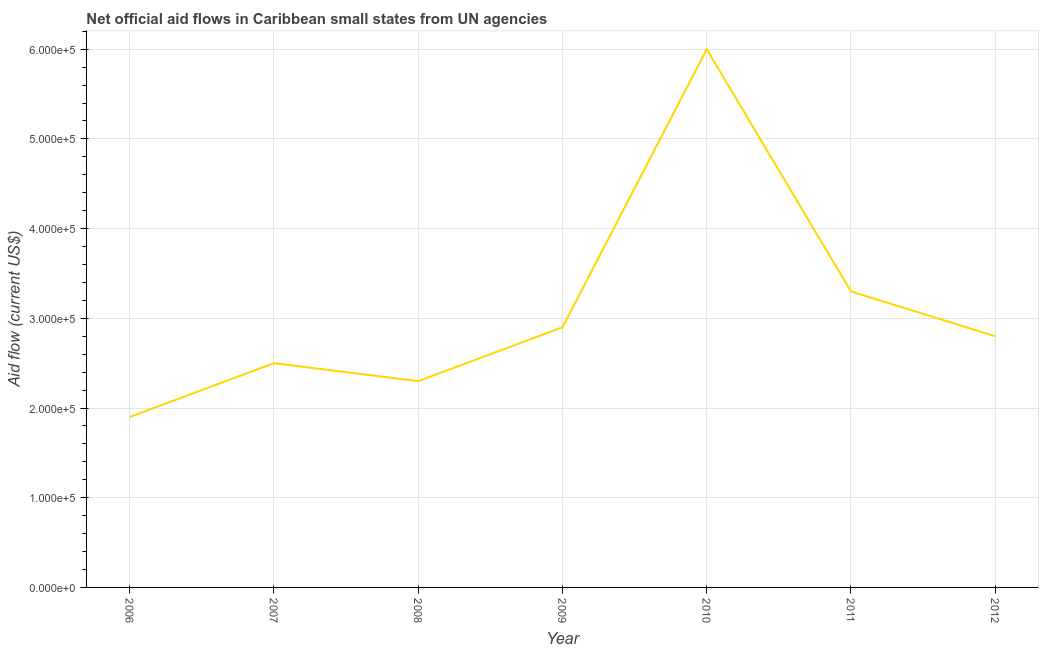What is the net official flows from un agencies in 2007?
Give a very brief answer. 2.50e+05. Across all years, what is the maximum net official flows from un agencies?
Make the answer very short. 6.00e+05. Across all years, what is the minimum net official flows from un agencies?
Offer a terse response. 1.90e+05. What is the sum of the net official flows from un agencies?
Provide a succinct answer. 2.17e+06. What is the difference between the net official flows from un agencies in 2009 and 2011?
Ensure brevity in your answer.  -4.00e+04. What is the average net official flows from un agencies per year?
Give a very brief answer. 3.10e+05. What is the median net official flows from un agencies?
Your response must be concise. 2.80e+05. In how many years, is the net official flows from un agencies greater than 300000 US$?
Your response must be concise. 2. Do a majority of the years between 2010 and 2009 (inclusive) have net official flows from un agencies greater than 380000 US$?
Keep it short and to the point. No. What is the ratio of the net official flows from un agencies in 2006 to that in 2009?
Give a very brief answer. 0.66. Is the net official flows from un agencies in 2010 less than that in 2011?
Offer a very short reply. No. What is the difference between the highest and the lowest net official flows from un agencies?
Your answer should be very brief. 4.10e+05. Does the net official flows from un agencies monotonically increase over the years?
Your answer should be very brief. No. How many years are there in the graph?
Provide a short and direct response. 7. Are the values on the major ticks of Y-axis written in scientific E-notation?
Keep it short and to the point. Yes. Does the graph contain grids?
Offer a terse response. Yes. What is the title of the graph?
Your response must be concise. Net official aid flows in Caribbean small states from UN agencies. What is the Aid flow (current US$) of 2006?
Your answer should be compact. 1.90e+05. What is the Aid flow (current US$) in 2007?
Ensure brevity in your answer.  2.50e+05. What is the Aid flow (current US$) in 2008?
Offer a terse response. 2.30e+05. What is the Aid flow (current US$) of 2010?
Provide a succinct answer. 6.00e+05. What is the Aid flow (current US$) of 2012?
Provide a succinct answer. 2.80e+05. What is the difference between the Aid flow (current US$) in 2006 and 2007?
Keep it short and to the point. -6.00e+04. What is the difference between the Aid flow (current US$) in 2006 and 2010?
Ensure brevity in your answer.  -4.10e+05. What is the difference between the Aid flow (current US$) in 2006 and 2011?
Offer a terse response. -1.40e+05. What is the difference between the Aid flow (current US$) in 2006 and 2012?
Make the answer very short. -9.00e+04. What is the difference between the Aid flow (current US$) in 2007 and 2008?
Your answer should be very brief. 2.00e+04. What is the difference between the Aid flow (current US$) in 2007 and 2009?
Make the answer very short. -4.00e+04. What is the difference between the Aid flow (current US$) in 2007 and 2010?
Give a very brief answer. -3.50e+05. What is the difference between the Aid flow (current US$) in 2007 and 2011?
Give a very brief answer. -8.00e+04. What is the difference between the Aid flow (current US$) in 2008 and 2009?
Keep it short and to the point. -6.00e+04. What is the difference between the Aid flow (current US$) in 2008 and 2010?
Ensure brevity in your answer.  -3.70e+05. What is the difference between the Aid flow (current US$) in 2009 and 2010?
Your answer should be very brief. -3.10e+05. What is the difference between the Aid flow (current US$) in 2009 and 2011?
Give a very brief answer. -4.00e+04. What is the difference between the Aid flow (current US$) in 2010 and 2011?
Your answer should be very brief. 2.70e+05. What is the ratio of the Aid flow (current US$) in 2006 to that in 2007?
Keep it short and to the point. 0.76. What is the ratio of the Aid flow (current US$) in 2006 to that in 2008?
Your answer should be compact. 0.83. What is the ratio of the Aid flow (current US$) in 2006 to that in 2009?
Your answer should be very brief. 0.66. What is the ratio of the Aid flow (current US$) in 2006 to that in 2010?
Your answer should be compact. 0.32. What is the ratio of the Aid flow (current US$) in 2006 to that in 2011?
Ensure brevity in your answer.  0.58. What is the ratio of the Aid flow (current US$) in 2006 to that in 2012?
Make the answer very short. 0.68. What is the ratio of the Aid flow (current US$) in 2007 to that in 2008?
Provide a short and direct response. 1.09. What is the ratio of the Aid flow (current US$) in 2007 to that in 2009?
Provide a short and direct response. 0.86. What is the ratio of the Aid flow (current US$) in 2007 to that in 2010?
Your answer should be very brief. 0.42. What is the ratio of the Aid flow (current US$) in 2007 to that in 2011?
Your answer should be very brief. 0.76. What is the ratio of the Aid flow (current US$) in 2007 to that in 2012?
Your answer should be very brief. 0.89. What is the ratio of the Aid flow (current US$) in 2008 to that in 2009?
Your answer should be compact. 0.79. What is the ratio of the Aid flow (current US$) in 2008 to that in 2010?
Give a very brief answer. 0.38. What is the ratio of the Aid flow (current US$) in 2008 to that in 2011?
Provide a short and direct response. 0.7. What is the ratio of the Aid flow (current US$) in 2008 to that in 2012?
Your response must be concise. 0.82. What is the ratio of the Aid flow (current US$) in 2009 to that in 2010?
Your answer should be very brief. 0.48. What is the ratio of the Aid flow (current US$) in 2009 to that in 2011?
Your response must be concise. 0.88. What is the ratio of the Aid flow (current US$) in 2009 to that in 2012?
Offer a terse response. 1.04. What is the ratio of the Aid flow (current US$) in 2010 to that in 2011?
Your response must be concise. 1.82. What is the ratio of the Aid flow (current US$) in 2010 to that in 2012?
Keep it short and to the point. 2.14. What is the ratio of the Aid flow (current US$) in 2011 to that in 2012?
Offer a terse response. 1.18. 